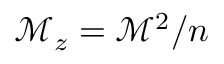<formula> <loc_0><loc_0><loc_500><loc_500>\mathcal { M } _ { z } = \mathcal { M } ^ { 2 } / n</formula> 